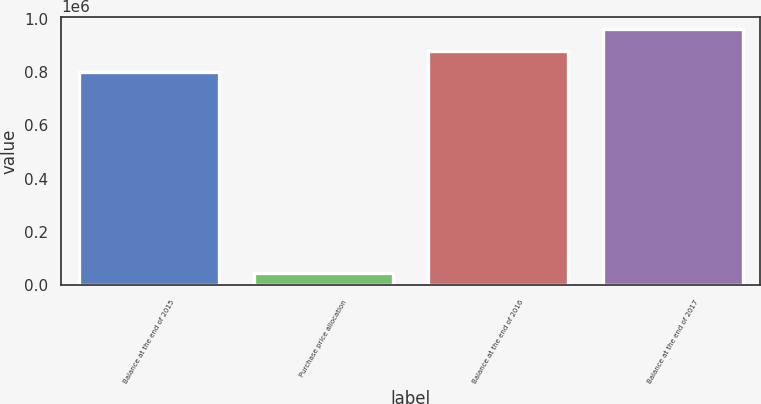Convert chart to OTSL. <chart><loc_0><loc_0><loc_500><loc_500><bar_chart><fcel>Balance at the end of 2015<fcel>Purchase price allocation<fcel>Balance at the end of 2016<fcel>Balance at the end of 2017<nl><fcel>799182<fcel>46940<fcel>879788<fcel>960395<nl></chart> 